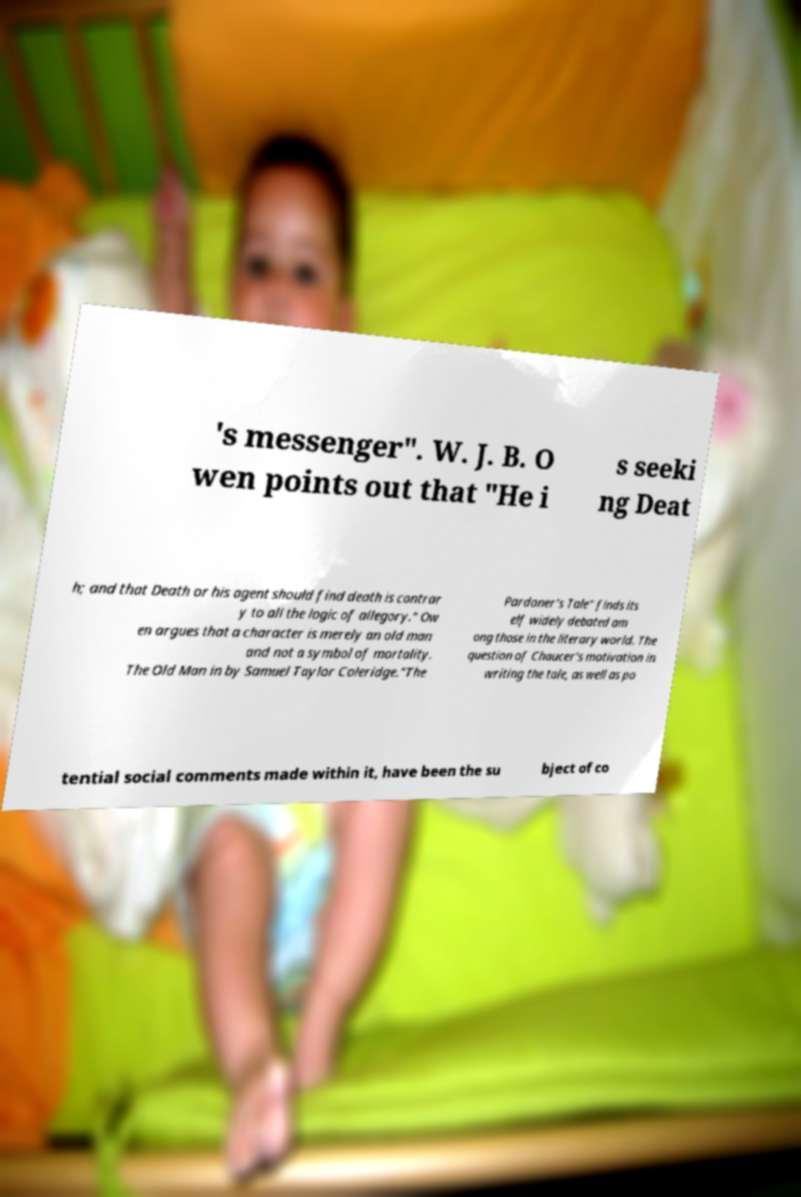There's text embedded in this image that I need extracted. Can you transcribe it verbatim? 's messenger". W. J. B. O wen points out that "He i s seeki ng Deat h; and that Death or his agent should find death is contrar y to all the logic of allegory." Ow en argues that a character is merely an old man and not a symbol of mortality. The Old Man in by Samuel Taylor Coleridge."The Pardoner's Tale" finds its elf widely debated am ong those in the literary world. The question of Chaucer's motivation in writing the tale, as well as po tential social comments made within it, have been the su bject of co 